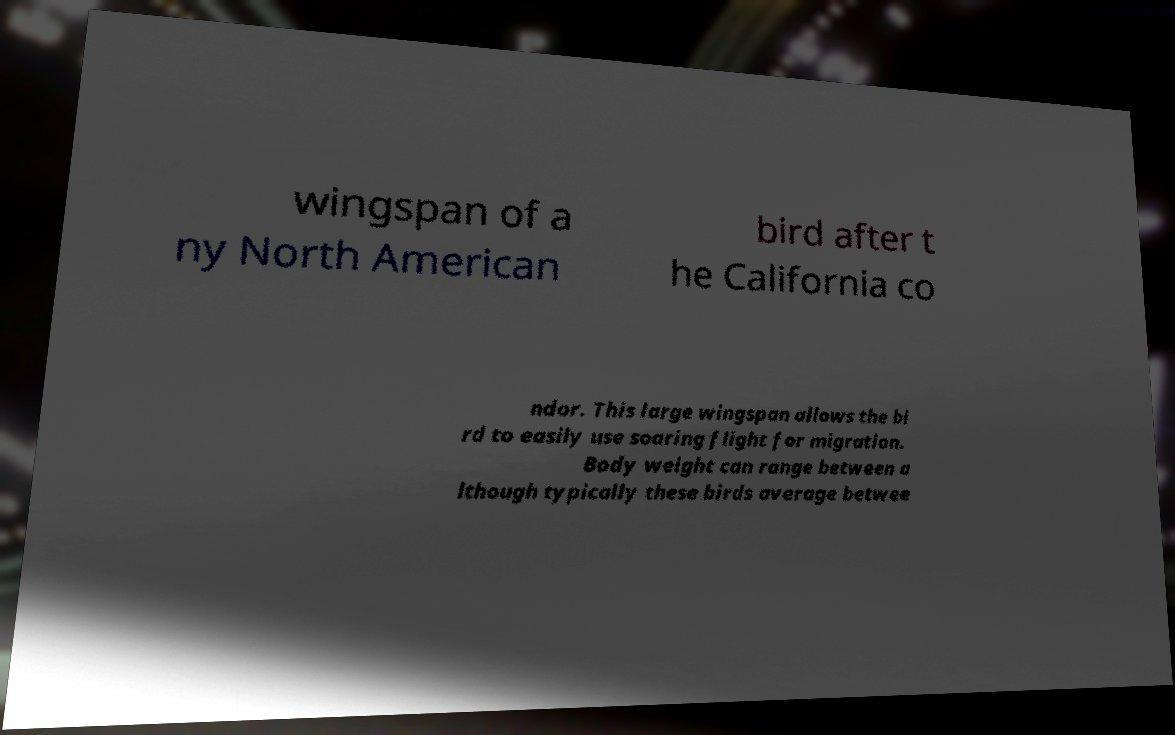Please identify and transcribe the text found in this image. wingspan of a ny North American bird after t he California co ndor. This large wingspan allows the bi rd to easily use soaring flight for migration. Body weight can range between a lthough typically these birds average betwee 